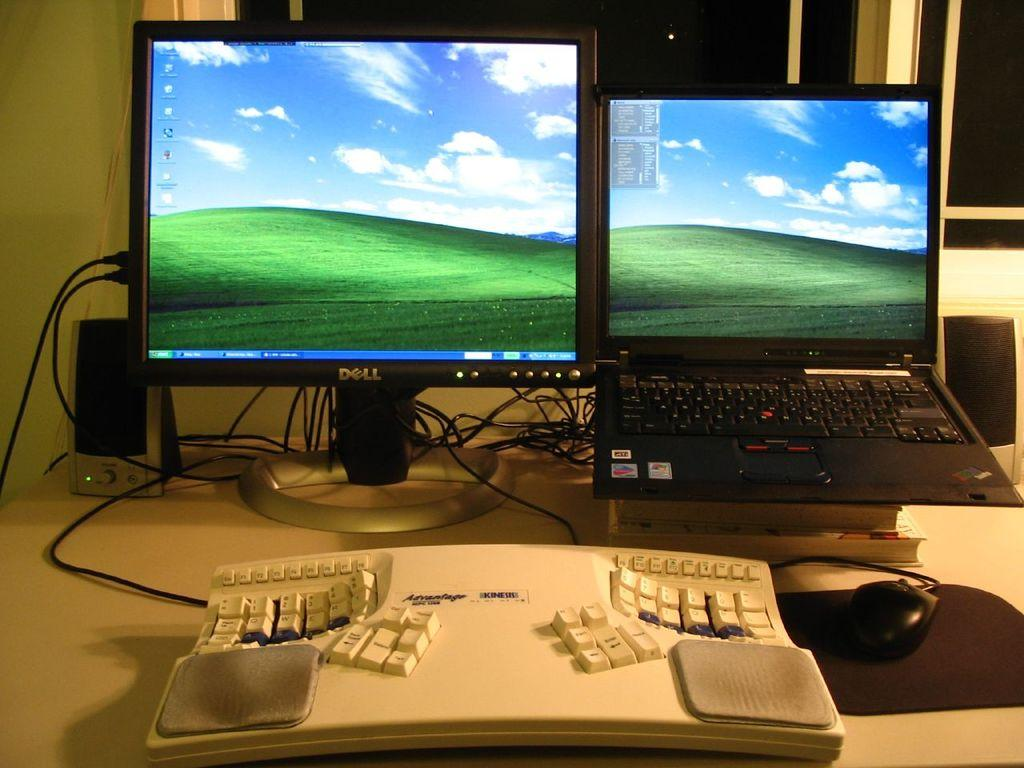<image>
Create a compact narrative representing the image presented. Dell computer monitor next to a black laptop. 